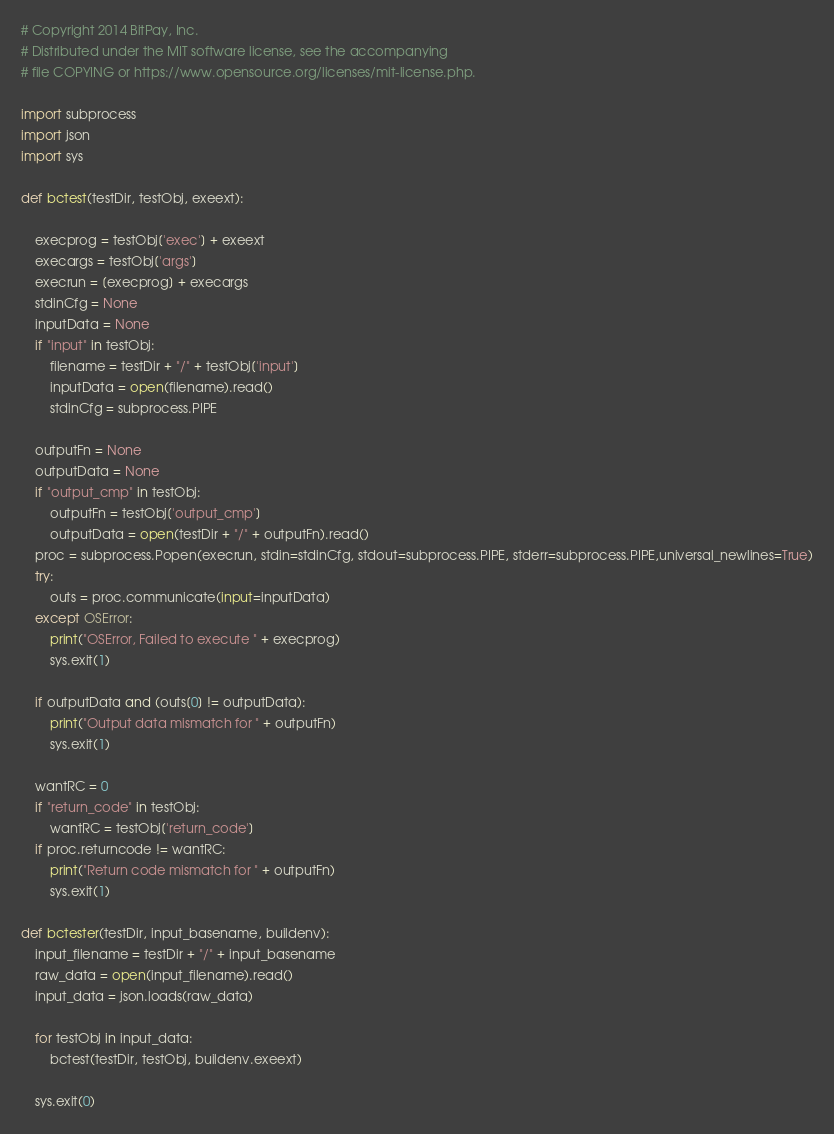Convert code to text. <code><loc_0><loc_0><loc_500><loc_500><_Python_># Copyright 2014 BitPay, Inc.
# Distributed under the MIT software license, see the accompanying
# file COPYING or https://www.opensource.org/licenses/mit-license.php.

import subprocess
import json
import sys

def bctest(testDir, testObj, exeext):

	execprog = testObj['exec'] + exeext
	execargs = testObj['args']
	execrun = [execprog] + execargs
	stdinCfg = None
	inputData = None
	if "input" in testObj:
		filename = testDir + "/" + testObj['input']
		inputData = open(filename).read()
		stdinCfg = subprocess.PIPE

	outputFn = None
	outputData = None
	if "output_cmp" in testObj:
		outputFn = testObj['output_cmp']
		outputData = open(testDir + "/" + outputFn).read()
	proc = subprocess.Popen(execrun, stdin=stdinCfg, stdout=subprocess.PIPE, stderr=subprocess.PIPE,universal_newlines=True)
	try:
		outs = proc.communicate(input=inputData)
	except OSError:
		print("OSError, Failed to execute " + execprog)
		sys.exit(1)

	if outputData and (outs[0] != outputData):
		print("Output data mismatch for " + outputFn)
		sys.exit(1)

	wantRC = 0
	if "return_code" in testObj:
		wantRC = testObj['return_code']
	if proc.returncode != wantRC:
		print("Return code mismatch for " + outputFn)
		sys.exit(1)

def bctester(testDir, input_basename, buildenv):
	input_filename = testDir + "/" + input_basename
	raw_data = open(input_filename).read()
	input_data = json.loads(raw_data)

	for testObj in input_data:
		bctest(testDir, testObj, buildenv.exeext)

	sys.exit(0)

</code> 